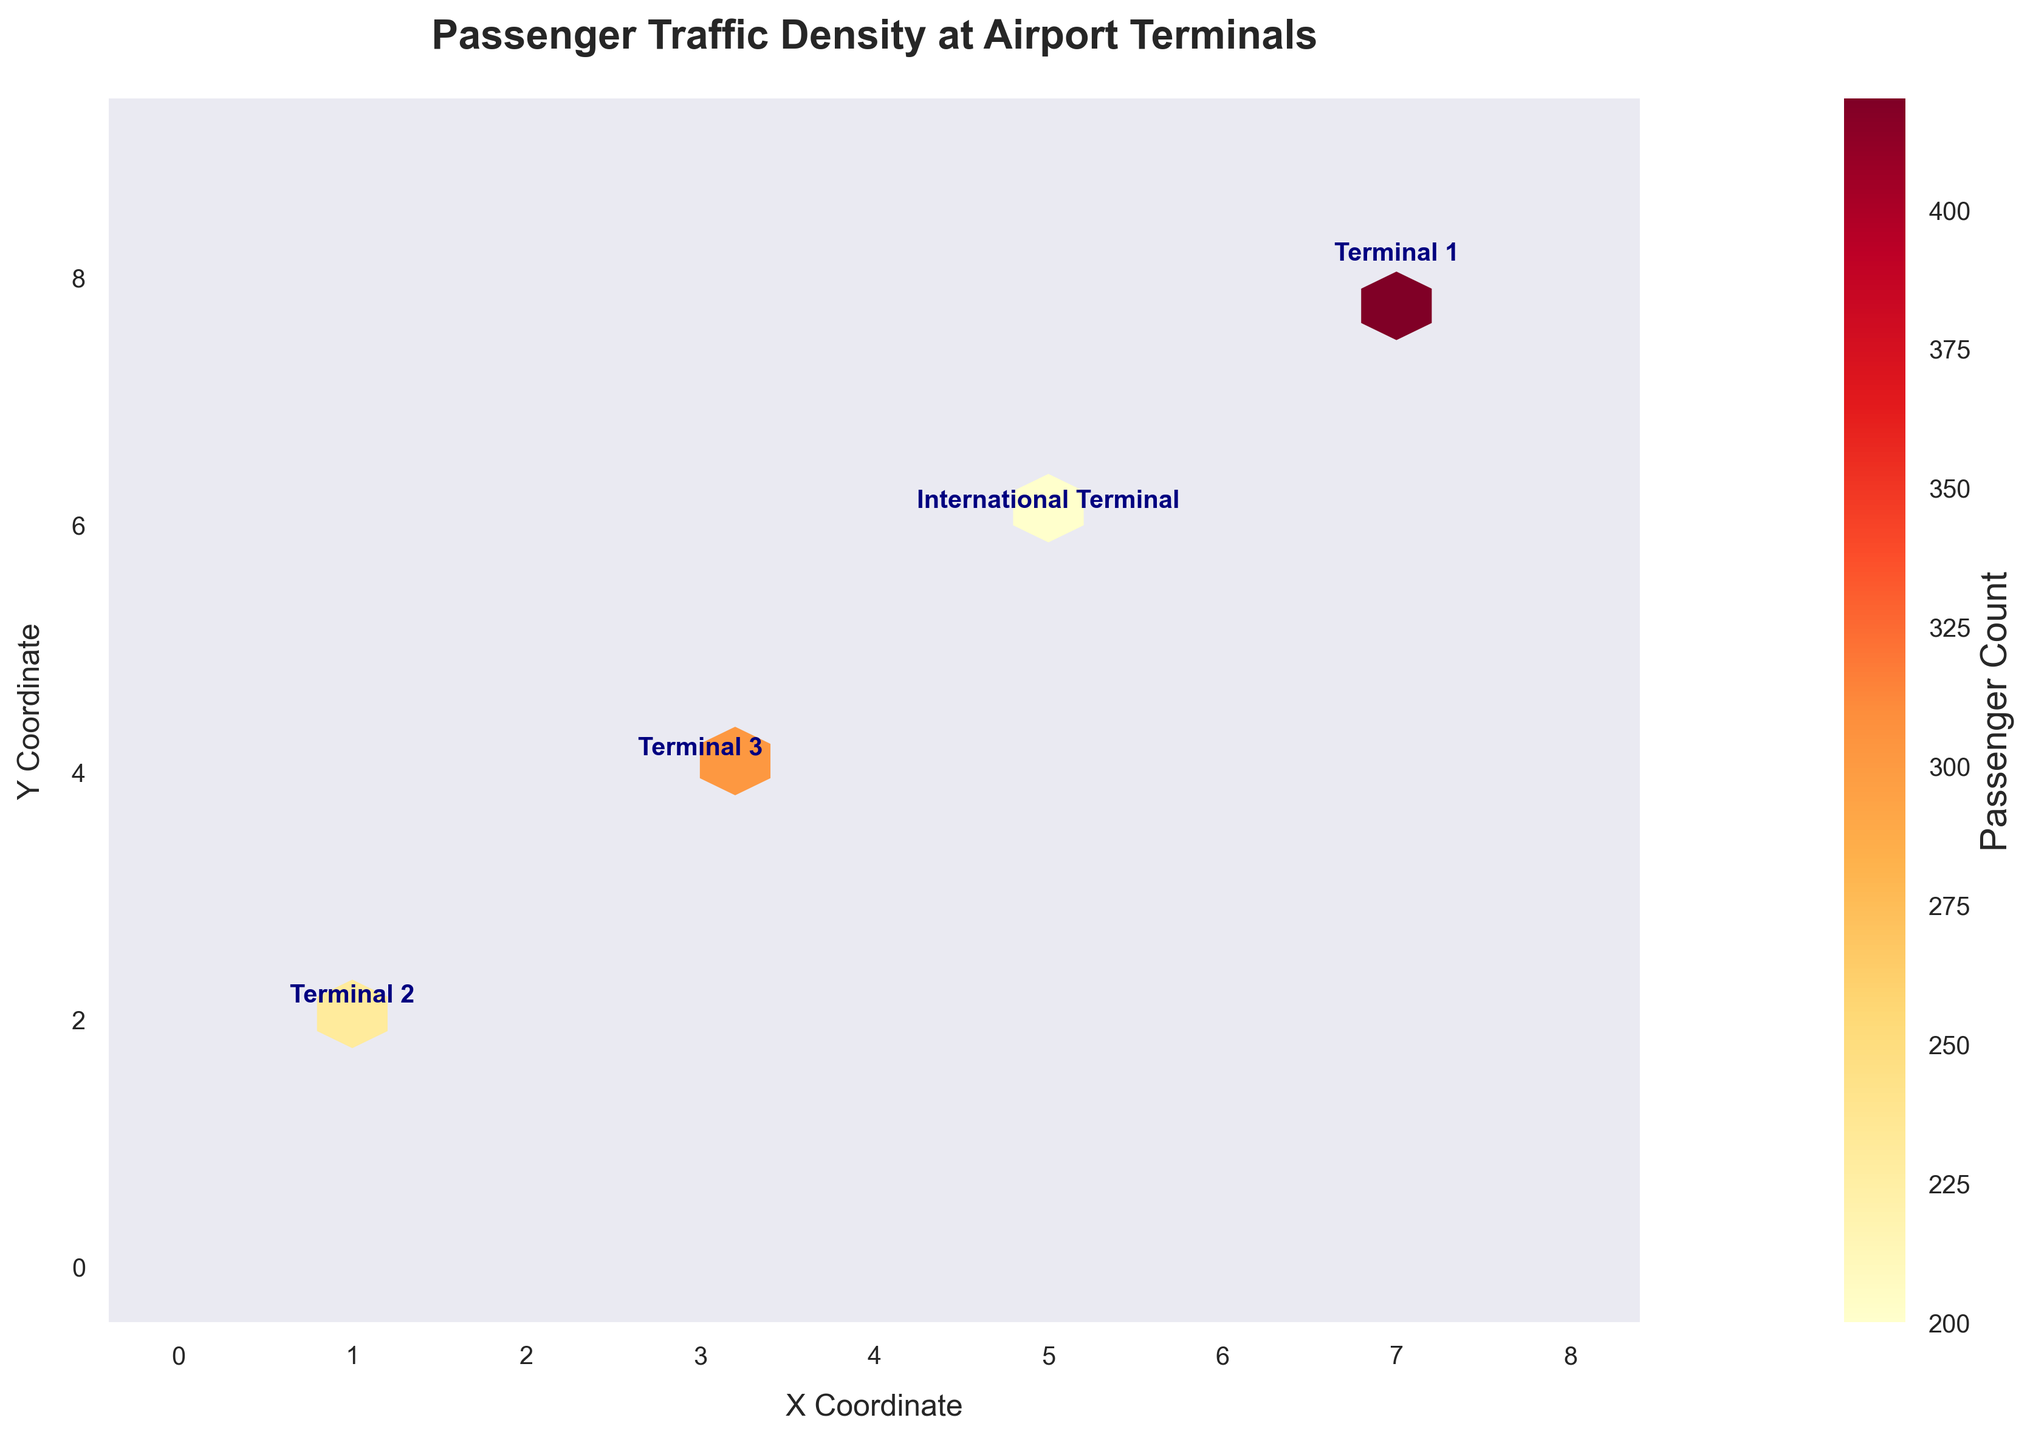What is the title of the plot? The title is typically found at the top of the plot, indicating what the plot is about. In this case, it is labeled clearly as a heading.
Answer: Passenger Traffic Density at Airport Terminals What does the color intensity in the hexagons represent? The legend on the right side of the plot indicates that different shades and intensities of color represent the Passenger Count, with darker or more intense colors indicating higher passenger counts.
Answer: Passenger Count Which terminal has the highest passenger traffic density on the plot? By looking at the annotated terminals and the intensity of the colors in the hexagons, the International Terminal, with the dark hexagons, indicates the highest traffic density.
Answer: International Terminal How does the passenger traffic density at Terminal 2 compare to Terminal 3? Comparing the color intensities and the annotated labels, Terminal 2 has overall darker hexagons than Terminal 3, indicating higher passenger counts at Terminal 2.
Answer: Higher at Terminal 2 Between which coordinates does the traffic density range? The axis labels and ticks give this information. The X coordinate ranges from 0 to 8, and the Y coordinate ranges from 0 to 9.
Answer: X: 0-8, Y: 0-9 What does the color bar next to the hexbin plot indicate? The color bar, sometimes called a legend, is labeled and shows that the color gradations correspond to the Passenger Count values.
Answer: Passenger Count At which coordinate is Terminal 1 located and what is its passenger count? Terminal 1 can be identified by the annotation on the plot at its coordinates (1, 2). Referring to the color bar, the exact passenger count is not obvious from hexbin colors but can be inferred from the data annotation.
Answer: (1, 2) Which terminal appears at coordinates (7, 8), and how does its passenger count compare to other terminals? The terminal at coordinates (7, 8) is the International Terminal. By comparing color intensities, it has the highest passenger count compared to other terminals.
Answer: International Terminal, highest How can you determine passenger traffic changes throughout the day at Terminal 1 from the plot? Observing the labels and shades at Terminal 1, and knowing that they are summarized, we can infer variations. However, detailed hourly changes are not directly visible; a time-series plot would be clearer.
Answer: Not explicitly shown 